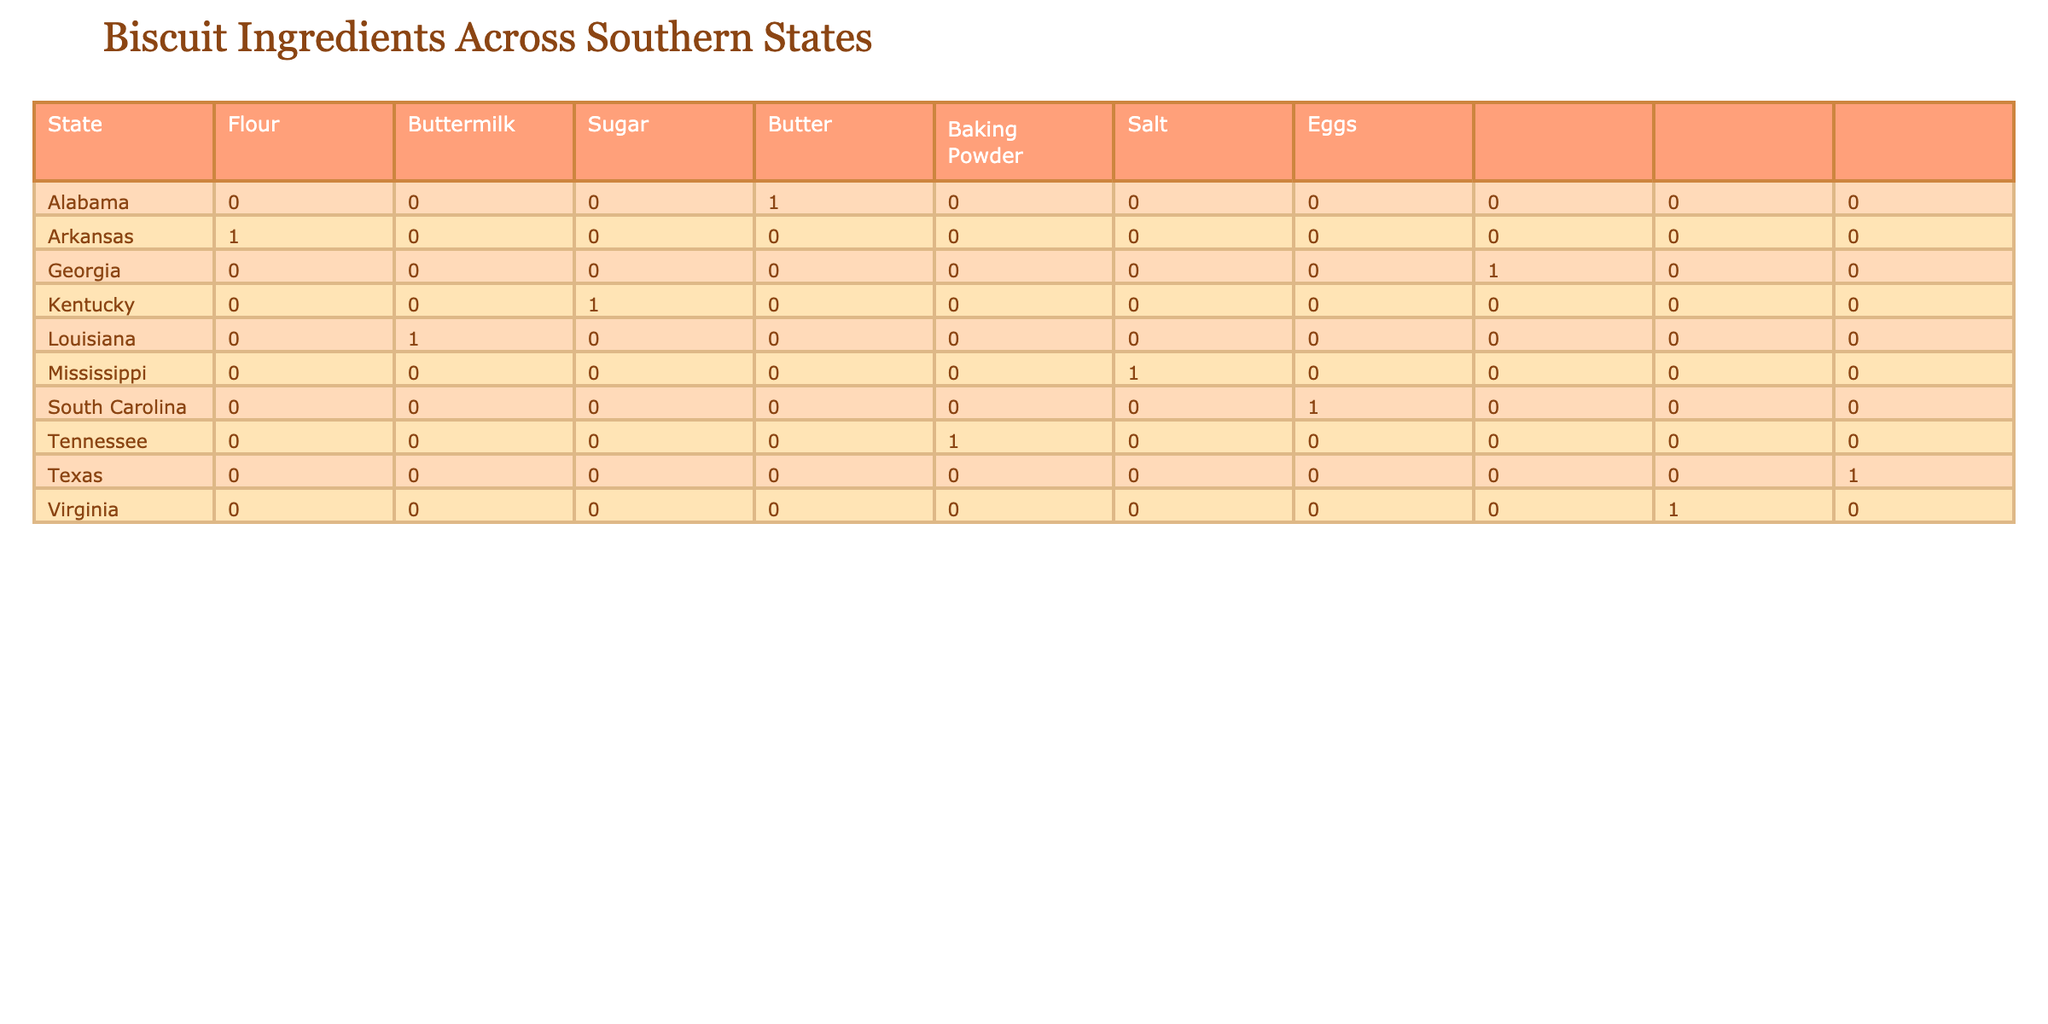What type of flour is commonly used in Tennessee's biscuit recipes? Tennessee's biscuit recipe uses "All-Purpose" flour as per the table data.
Answer: All-Purpose Which states use buttermilk in their biscuit recipes? By examining the table, Alabama, Georgia, Tennessee, Louisiana, Kentucky, Texas, and Virginia all have "Yes" under the buttermilk column.
Answer: Alabama, Georgia, Tennessee, Louisiana, Kentucky, Texas, Virginia Is there any state that uses butter in their biscuit recipes without buttermilk? Checking the given data, Mississippi and Arkansas use butter but have a "No" for buttermilk. Therefore, both states fit this description.
Answer: Mississippi, Arkansas How many states use Self-Raising flour? Looking at the table, the states that use Self-Raising flour are Georgia, Mississippi, South Carolina, Texas, and Virginia. That's a total of five states.
Answer: 5 What is the average amount of sugar used in the biscuit recipes that include it? To find the average sugar amount, sum the sugar amounts in tablespoons for recipes with sugar: 1 (Alabama) + 1 (Georgia) + 2 (Tennessee) + 1 (Mississippi) + 0 (Louisiana) + 2 (South Carolina) + 3 (Texas) + 2 (Virginia) = 12 tablespoons. Since 6 states included sugar, the average is 12/6 = 2 tablespoons.
Answer: 2 tablespoons Are there any states that use eggs but have no buttermilk? From the table, Arkansas and Mississippi use eggs while listing "No" for buttermilk. This confirms both states utilize eggs without buttermilk.
Answer: Arkansas, Mississippi Which state has the highest amount of butter listed in its biscuit recipe? The table indicates that Texas has the highest amount of butter with "1/2 cup" compared to all the other states listed.
Answer: Texas Do many states in this table use baking powder as an ingredient? Yes, upon reviewing the table, all states except for Arkansas have "Yes" under the baking powder column. This shows that most states utilize baking powder in their recipes.
Answer: Yes 